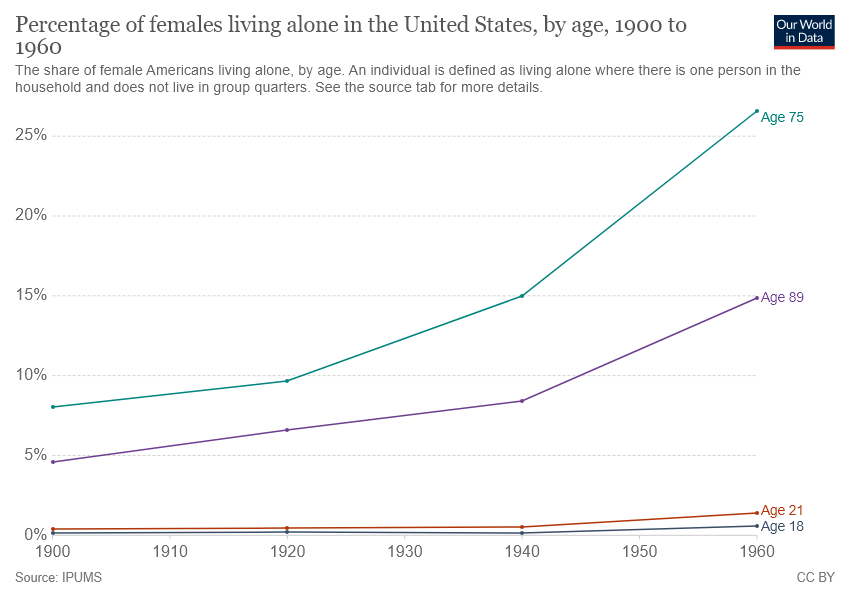Point out several critical features in this image. The gap between age 75 and age 89 becomes largest in 1960. The green line represents the age of 75. 